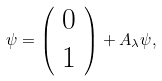<formula> <loc_0><loc_0><loc_500><loc_500>\psi = \left ( \begin{array} { l l l } 0 \\ 1 \end{array} \right ) + A _ { \lambda } \psi ,</formula> 